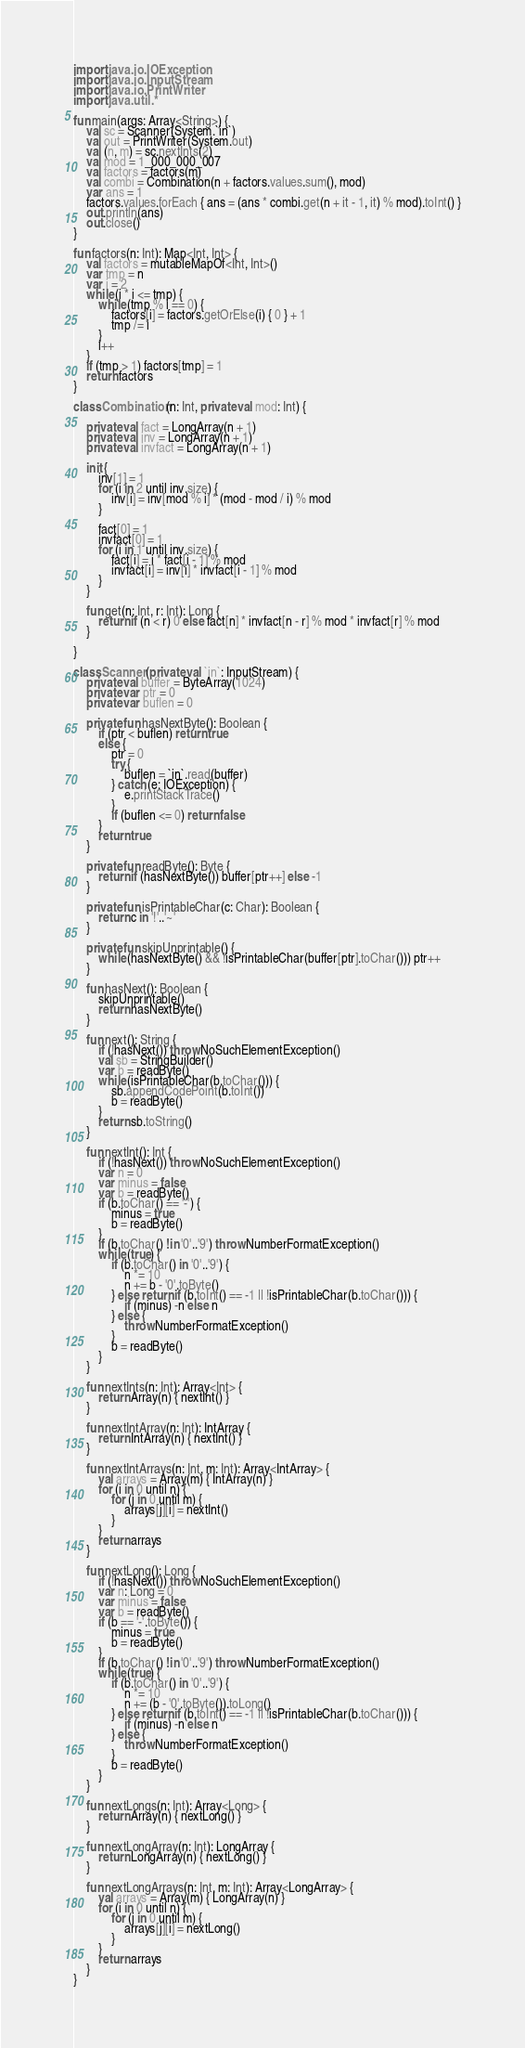<code> <loc_0><loc_0><loc_500><loc_500><_Kotlin_>import java.io.IOException
import java.io.InputStream
import java.io.PrintWriter
import java.util.*

fun main(args: Array<String>) {
    val sc = Scanner(System.`in`)
    val out = PrintWriter(System.out)
    val (n, m) = sc.nextInts(2)
    val mod = 1_000_000_007
    val factors = factors(m)
    val combi = Combination(n + factors.values.sum(), mod)
    var ans = 1
    factors.values.forEach { ans = (ans * combi.get(n + it - 1, it) % mod).toInt() }
    out.println(ans)
    out.close()
}

fun factors(n: Int): Map<Int, Int> {
    val factors = mutableMapOf<Int, Int>()
    var tmp = n
    var i = 2
    while (i * i <= tmp) {
        while (tmp % i == 0) {
            factors[i] = factors.getOrElse(i) { 0 } + 1
            tmp /= i
        }
        i++
    }
    if (tmp > 1) factors[tmp] = 1
    return factors
}

class Combination(n: Int, private val mod: Int) {

    private val fact = LongArray(n + 1)
    private val inv = LongArray(n + 1)
    private val invfact = LongArray(n + 1)

    init {
        inv[1] = 1
        for (i in 2 until inv.size) {
            inv[i] = inv[mod % i] * (mod - mod / i) % mod
        }

        fact[0] = 1
        invfact[0] = 1
        for (i in 1 until inv.size) {
            fact[i] = i * fact[i - 1] % mod
            invfact[i] = inv[i] * invfact[i - 1] % mod
        }
    }

    fun get(n: Int, r: Int): Long {
        return if (n < r) 0 else fact[n] * invfact[n - r] % mod * invfact[r] % mod
    }

}

class Scanner(private val `in`: InputStream) {
    private val buffer = ByteArray(1024)
    private var ptr = 0
    private var buflen = 0

    private fun hasNextByte(): Boolean {
        if (ptr < buflen) return true
        else {
            ptr = 0
            try {
                buflen = `in`.read(buffer)
            } catch (e: IOException) {
                e.printStackTrace()
            }
            if (buflen <= 0) return false
        }
        return true
    }

    private fun readByte(): Byte {
        return if (hasNextByte()) buffer[ptr++] else -1
    }

    private fun isPrintableChar(c: Char): Boolean {
        return c in '!'..'~'
    }

    private fun skipUnprintable() {
        while (hasNextByte() && !isPrintableChar(buffer[ptr].toChar())) ptr++
    }

    fun hasNext(): Boolean {
        skipUnprintable()
        return hasNextByte()
    }

    fun next(): String {
        if (!hasNext()) throw NoSuchElementException()
        val sb = StringBuilder()
        var b = readByte()
        while (isPrintableChar(b.toChar())) {
            sb.appendCodePoint(b.toInt())
            b = readByte()
        }
        return sb.toString()
    }

    fun nextInt(): Int {
        if (!hasNext()) throw NoSuchElementException()
        var n = 0
        var minus = false
        var b = readByte()
        if (b.toChar() == '-') {
            minus = true
            b = readByte()
        }
        if (b.toChar() !in '0'..'9') throw NumberFormatException()
        while (true) {
            if (b.toChar() in '0'..'9') {
                n *= 10
                n += b - '0'.toByte()
            } else return if (b.toInt() == -1 || !isPrintableChar(b.toChar())) {
                if (minus) -n else n
            } else {
                throw NumberFormatException()
            }
            b = readByte()
        }
    }

    fun nextInts(n: Int): Array<Int> {
        return Array(n) { nextInt() }
    }

    fun nextIntArray(n: Int): IntArray {
        return IntArray(n) { nextInt() }
    }

    fun nextIntArrays(n: Int, m: Int): Array<IntArray> {
        val arrays = Array(m) { IntArray(n) }
        for (i in 0 until n) {
            for (j in 0 until m) {
                arrays[j][i] = nextInt()
            }
        }
        return arrays
    }

    fun nextLong(): Long {
        if (!hasNext()) throw NoSuchElementException()
        var n: Long = 0
        var minus = false
        var b = readByte()
        if (b == '-'.toByte()) {
            minus = true
            b = readByte()
        }
        if (b.toChar() !in '0'..'9') throw NumberFormatException()
        while (true) {
            if (b.toChar() in '0'..'9') {
                n *= 10
                n += (b - '0'.toByte()).toLong()
            } else return if (b.toInt() == -1 || !isPrintableChar(b.toChar())) {
                if (minus) -n else n
            } else {
                throw NumberFormatException()
            }
            b = readByte()
        }
    }

    fun nextLongs(n: Int): Array<Long> {
        return Array(n) { nextLong() }
    }

    fun nextLongArray(n: Int): LongArray {
        return LongArray(n) { nextLong() }
    }

    fun nextLongArrays(n: Int, m: Int): Array<LongArray> {
        val arrays = Array(m) { LongArray(n) }
        for (i in 0 until n) {
            for (j in 0 until m) {
                arrays[j][i] = nextLong()
            }
        }
        return arrays
    }
}
</code> 